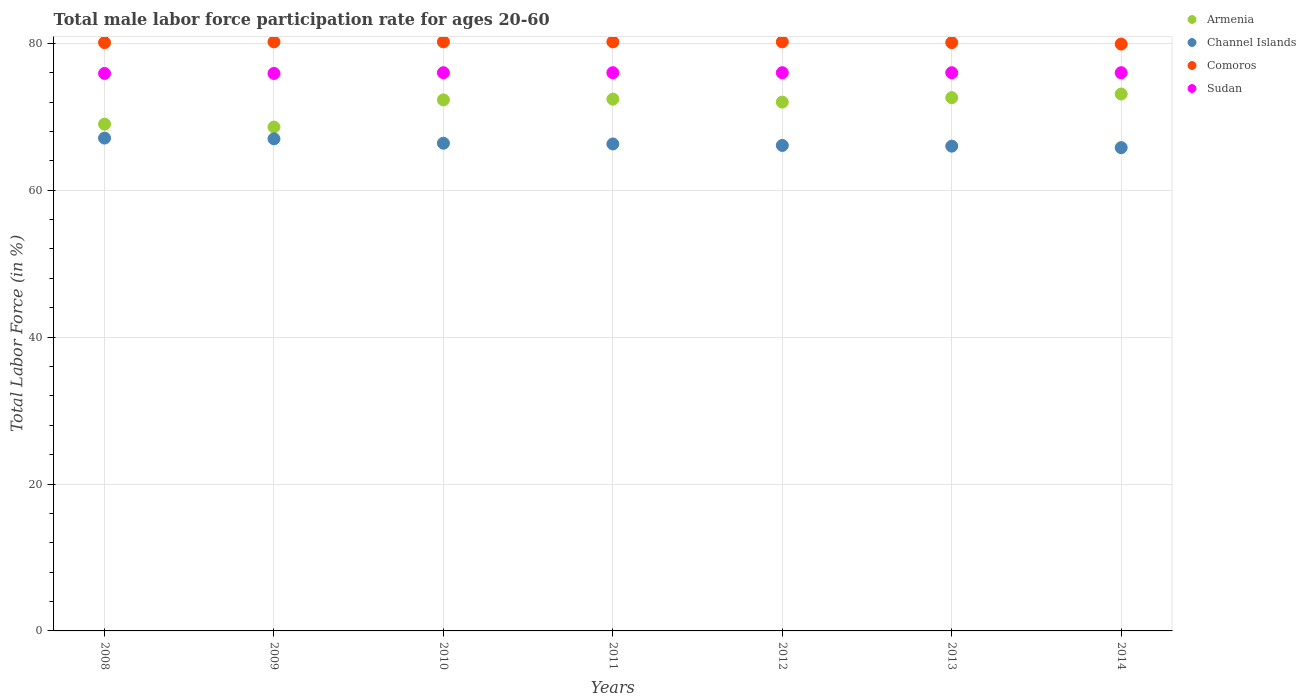How many different coloured dotlines are there?
Your answer should be compact. 4. Is the number of dotlines equal to the number of legend labels?
Provide a succinct answer. Yes. What is the male labor force participation rate in Sudan in 2012?
Your response must be concise. 76. Across all years, what is the maximum male labor force participation rate in Sudan?
Make the answer very short. 76. Across all years, what is the minimum male labor force participation rate in Comoros?
Keep it short and to the point. 79.9. In which year was the male labor force participation rate in Comoros minimum?
Your response must be concise. 2014. What is the total male labor force participation rate in Comoros in the graph?
Provide a short and direct response. 560.9. What is the difference between the male labor force participation rate in Channel Islands in 2009 and that in 2014?
Provide a short and direct response. 1.2. What is the difference between the male labor force participation rate in Comoros in 2011 and the male labor force participation rate in Armenia in 2008?
Your response must be concise. 11.2. What is the average male labor force participation rate in Channel Islands per year?
Offer a very short reply. 66.39. In the year 2008, what is the difference between the male labor force participation rate in Armenia and male labor force participation rate in Comoros?
Provide a succinct answer. -11.1. In how many years, is the male labor force participation rate in Channel Islands greater than 72 %?
Offer a very short reply. 0. What is the ratio of the male labor force participation rate in Sudan in 2009 to that in 2012?
Provide a short and direct response. 1. Is the difference between the male labor force participation rate in Armenia in 2012 and 2014 greater than the difference between the male labor force participation rate in Comoros in 2012 and 2014?
Provide a short and direct response. No. What is the difference between the highest and the lowest male labor force participation rate in Channel Islands?
Offer a very short reply. 1.3. Is the sum of the male labor force participation rate in Comoros in 2008 and 2011 greater than the maximum male labor force participation rate in Sudan across all years?
Provide a succinct answer. Yes. Is it the case that in every year, the sum of the male labor force participation rate in Armenia and male labor force participation rate in Channel Islands  is greater than the male labor force participation rate in Comoros?
Your answer should be compact. Yes. How many years are there in the graph?
Make the answer very short. 7. Are the values on the major ticks of Y-axis written in scientific E-notation?
Offer a terse response. No. Does the graph contain any zero values?
Provide a succinct answer. No. Does the graph contain grids?
Your response must be concise. Yes. How many legend labels are there?
Provide a succinct answer. 4. What is the title of the graph?
Your response must be concise. Total male labor force participation rate for ages 20-60. Does "Comoros" appear as one of the legend labels in the graph?
Make the answer very short. Yes. What is the label or title of the X-axis?
Keep it short and to the point. Years. What is the label or title of the Y-axis?
Provide a short and direct response. Total Labor Force (in %). What is the Total Labor Force (in %) of Armenia in 2008?
Your answer should be compact. 69. What is the Total Labor Force (in %) of Channel Islands in 2008?
Keep it short and to the point. 67.1. What is the Total Labor Force (in %) in Comoros in 2008?
Ensure brevity in your answer.  80.1. What is the Total Labor Force (in %) of Sudan in 2008?
Provide a succinct answer. 75.9. What is the Total Labor Force (in %) in Armenia in 2009?
Your answer should be very brief. 68.6. What is the Total Labor Force (in %) of Channel Islands in 2009?
Your answer should be very brief. 67. What is the Total Labor Force (in %) of Comoros in 2009?
Ensure brevity in your answer.  80.2. What is the Total Labor Force (in %) in Sudan in 2009?
Keep it short and to the point. 75.9. What is the Total Labor Force (in %) of Armenia in 2010?
Your answer should be very brief. 72.3. What is the Total Labor Force (in %) in Channel Islands in 2010?
Give a very brief answer. 66.4. What is the Total Labor Force (in %) of Comoros in 2010?
Offer a terse response. 80.2. What is the Total Labor Force (in %) of Sudan in 2010?
Your answer should be compact. 76. What is the Total Labor Force (in %) of Armenia in 2011?
Give a very brief answer. 72.4. What is the Total Labor Force (in %) of Channel Islands in 2011?
Provide a succinct answer. 66.3. What is the Total Labor Force (in %) of Comoros in 2011?
Keep it short and to the point. 80.2. What is the Total Labor Force (in %) of Sudan in 2011?
Provide a short and direct response. 76. What is the Total Labor Force (in %) of Armenia in 2012?
Your answer should be compact. 72. What is the Total Labor Force (in %) of Channel Islands in 2012?
Give a very brief answer. 66.1. What is the Total Labor Force (in %) of Comoros in 2012?
Your answer should be compact. 80.2. What is the Total Labor Force (in %) in Armenia in 2013?
Provide a short and direct response. 72.6. What is the Total Labor Force (in %) of Channel Islands in 2013?
Your answer should be compact. 66. What is the Total Labor Force (in %) of Comoros in 2013?
Provide a succinct answer. 80.1. What is the Total Labor Force (in %) of Armenia in 2014?
Your answer should be compact. 73.1. What is the Total Labor Force (in %) in Channel Islands in 2014?
Ensure brevity in your answer.  65.8. What is the Total Labor Force (in %) in Comoros in 2014?
Your answer should be very brief. 79.9. Across all years, what is the maximum Total Labor Force (in %) in Armenia?
Your answer should be compact. 73.1. Across all years, what is the maximum Total Labor Force (in %) in Channel Islands?
Offer a terse response. 67.1. Across all years, what is the maximum Total Labor Force (in %) of Comoros?
Keep it short and to the point. 80.2. Across all years, what is the maximum Total Labor Force (in %) of Sudan?
Ensure brevity in your answer.  76. Across all years, what is the minimum Total Labor Force (in %) in Armenia?
Make the answer very short. 68.6. Across all years, what is the minimum Total Labor Force (in %) in Channel Islands?
Ensure brevity in your answer.  65.8. Across all years, what is the minimum Total Labor Force (in %) of Comoros?
Keep it short and to the point. 79.9. Across all years, what is the minimum Total Labor Force (in %) in Sudan?
Make the answer very short. 75.9. What is the total Total Labor Force (in %) in Channel Islands in the graph?
Provide a short and direct response. 464.7. What is the total Total Labor Force (in %) in Comoros in the graph?
Give a very brief answer. 560.9. What is the total Total Labor Force (in %) of Sudan in the graph?
Make the answer very short. 531.8. What is the difference between the Total Labor Force (in %) of Armenia in 2008 and that in 2009?
Make the answer very short. 0.4. What is the difference between the Total Labor Force (in %) of Comoros in 2008 and that in 2009?
Offer a very short reply. -0.1. What is the difference between the Total Labor Force (in %) in Armenia in 2008 and that in 2010?
Provide a short and direct response. -3.3. What is the difference between the Total Labor Force (in %) of Sudan in 2008 and that in 2010?
Give a very brief answer. -0.1. What is the difference between the Total Labor Force (in %) of Armenia in 2008 and that in 2012?
Offer a terse response. -3. What is the difference between the Total Labor Force (in %) of Armenia in 2008 and that in 2013?
Ensure brevity in your answer.  -3.6. What is the difference between the Total Labor Force (in %) of Sudan in 2008 and that in 2013?
Offer a terse response. -0.1. What is the difference between the Total Labor Force (in %) of Armenia in 2009 and that in 2010?
Keep it short and to the point. -3.7. What is the difference between the Total Labor Force (in %) of Armenia in 2009 and that in 2011?
Your answer should be compact. -3.8. What is the difference between the Total Labor Force (in %) in Channel Islands in 2009 and that in 2012?
Give a very brief answer. 0.9. What is the difference between the Total Labor Force (in %) in Comoros in 2009 and that in 2012?
Offer a very short reply. 0. What is the difference between the Total Labor Force (in %) in Sudan in 2009 and that in 2012?
Keep it short and to the point. -0.1. What is the difference between the Total Labor Force (in %) in Channel Islands in 2009 and that in 2014?
Offer a very short reply. 1.2. What is the difference between the Total Labor Force (in %) of Sudan in 2009 and that in 2014?
Offer a very short reply. -0.1. What is the difference between the Total Labor Force (in %) in Armenia in 2010 and that in 2011?
Provide a succinct answer. -0.1. What is the difference between the Total Labor Force (in %) in Comoros in 2010 and that in 2011?
Your answer should be very brief. 0. What is the difference between the Total Labor Force (in %) of Sudan in 2010 and that in 2011?
Offer a terse response. 0. What is the difference between the Total Labor Force (in %) of Sudan in 2010 and that in 2012?
Your response must be concise. 0. What is the difference between the Total Labor Force (in %) in Channel Islands in 2010 and that in 2013?
Your answer should be compact. 0.4. What is the difference between the Total Labor Force (in %) of Comoros in 2010 and that in 2013?
Your answer should be compact. 0.1. What is the difference between the Total Labor Force (in %) of Sudan in 2010 and that in 2013?
Your response must be concise. 0. What is the difference between the Total Labor Force (in %) in Channel Islands in 2010 and that in 2014?
Offer a terse response. 0.6. What is the difference between the Total Labor Force (in %) in Sudan in 2010 and that in 2014?
Offer a terse response. 0. What is the difference between the Total Labor Force (in %) in Armenia in 2011 and that in 2012?
Give a very brief answer. 0.4. What is the difference between the Total Labor Force (in %) in Channel Islands in 2011 and that in 2013?
Offer a terse response. 0.3. What is the difference between the Total Labor Force (in %) of Sudan in 2011 and that in 2013?
Provide a succinct answer. 0. What is the difference between the Total Labor Force (in %) of Armenia in 2011 and that in 2014?
Your answer should be compact. -0.7. What is the difference between the Total Labor Force (in %) in Comoros in 2011 and that in 2014?
Give a very brief answer. 0.3. What is the difference between the Total Labor Force (in %) in Channel Islands in 2012 and that in 2013?
Ensure brevity in your answer.  0.1. What is the difference between the Total Labor Force (in %) of Sudan in 2012 and that in 2013?
Your response must be concise. 0. What is the difference between the Total Labor Force (in %) of Channel Islands in 2012 and that in 2014?
Offer a terse response. 0.3. What is the difference between the Total Labor Force (in %) of Comoros in 2012 and that in 2014?
Provide a short and direct response. 0.3. What is the difference between the Total Labor Force (in %) in Sudan in 2012 and that in 2014?
Give a very brief answer. 0. What is the difference between the Total Labor Force (in %) in Armenia in 2013 and that in 2014?
Offer a terse response. -0.5. What is the difference between the Total Labor Force (in %) of Channel Islands in 2013 and that in 2014?
Give a very brief answer. 0.2. What is the difference between the Total Labor Force (in %) of Comoros in 2013 and that in 2014?
Your response must be concise. 0.2. What is the difference between the Total Labor Force (in %) in Armenia in 2008 and the Total Labor Force (in %) in Channel Islands in 2009?
Ensure brevity in your answer.  2. What is the difference between the Total Labor Force (in %) in Armenia in 2008 and the Total Labor Force (in %) in Comoros in 2009?
Offer a terse response. -11.2. What is the difference between the Total Labor Force (in %) in Channel Islands in 2008 and the Total Labor Force (in %) in Sudan in 2009?
Give a very brief answer. -8.8. What is the difference between the Total Labor Force (in %) of Armenia in 2008 and the Total Labor Force (in %) of Channel Islands in 2010?
Offer a terse response. 2.6. What is the difference between the Total Labor Force (in %) of Channel Islands in 2008 and the Total Labor Force (in %) of Sudan in 2010?
Your answer should be very brief. -8.9. What is the difference between the Total Labor Force (in %) in Comoros in 2008 and the Total Labor Force (in %) in Sudan in 2010?
Your answer should be very brief. 4.1. What is the difference between the Total Labor Force (in %) of Armenia in 2008 and the Total Labor Force (in %) of Sudan in 2011?
Offer a terse response. -7. What is the difference between the Total Labor Force (in %) in Comoros in 2008 and the Total Labor Force (in %) in Sudan in 2011?
Ensure brevity in your answer.  4.1. What is the difference between the Total Labor Force (in %) in Armenia in 2008 and the Total Labor Force (in %) in Channel Islands in 2012?
Ensure brevity in your answer.  2.9. What is the difference between the Total Labor Force (in %) of Armenia in 2008 and the Total Labor Force (in %) of Comoros in 2012?
Offer a very short reply. -11.2. What is the difference between the Total Labor Force (in %) of Channel Islands in 2008 and the Total Labor Force (in %) of Sudan in 2012?
Provide a short and direct response. -8.9. What is the difference between the Total Labor Force (in %) of Comoros in 2008 and the Total Labor Force (in %) of Sudan in 2012?
Provide a succinct answer. 4.1. What is the difference between the Total Labor Force (in %) in Armenia in 2008 and the Total Labor Force (in %) in Sudan in 2013?
Offer a terse response. -7. What is the difference between the Total Labor Force (in %) of Comoros in 2008 and the Total Labor Force (in %) of Sudan in 2013?
Provide a succinct answer. 4.1. What is the difference between the Total Labor Force (in %) of Armenia in 2008 and the Total Labor Force (in %) of Sudan in 2014?
Provide a succinct answer. -7. What is the difference between the Total Labor Force (in %) of Channel Islands in 2008 and the Total Labor Force (in %) of Comoros in 2014?
Provide a succinct answer. -12.8. What is the difference between the Total Labor Force (in %) in Channel Islands in 2008 and the Total Labor Force (in %) in Sudan in 2014?
Your answer should be very brief. -8.9. What is the difference between the Total Labor Force (in %) of Channel Islands in 2009 and the Total Labor Force (in %) of Comoros in 2010?
Offer a very short reply. -13.2. What is the difference between the Total Labor Force (in %) in Channel Islands in 2009 and the Total Labor Force (in %) in Sudan in 2010?
Provide a succinct answer. -9. What is the difference between the Total Labor Force (in %) in Comoros in 2009 and the Total Labor Force (in %) in Sudan in 2010?
Your answer should be very brief. 4.2. What is the difference between the Total Labor Force (in %) in Armenia in 2009 and the Total Labor Force (in %) in Channel Islands in 2011?
Your answer should be compact. 2.3. What is the difference between the Total Labor Force (in %) of Armenia in 2009 and the Total Labor Force (in %) of Sudan in 2011?
Ensure brevity in your answer.  -7.4. What is the difference between the Total Labor Force (in %) in Channel Islands in 2009 and the Total Labor Force (in %) in Comoros in 2011?
Give a very brief answer. -13.2. What is the difference between the Total Labor Force (in %) of Channel Islands in 2009 and the Total Labor Force (in %) of Sudan in 2011?
Provide a succinct answer. -9. What is the difference between the Total Labor Force (in %) in Armenia in 2009 and the Total Labor Force (in %) in Channel Islands in 2012?
Your answer should be very brief. 2.5. What is the difference between the Total Labor Force (in %) of Channel Islands in 2009 and the Total Labor Force (in %) of Comoros in 2012?
Ensure brevity in your answer.  -13.2. What is the difference between the Total Labor Force (in %) in Channel Islands in 2009 and the Total Labor Force (in %) in Sudan in 2012?
Ensure brevity in your answer.  -9. What is the difference between the Total Labor Force (in %) in Comoros in 2009 and the Total Labor Force (in %) in Sudan in 2012?
Give a very brief answer. 4.2. What is the difference between the Total Labor Force (in %) of Armenia in 2009 and the Total Labor Force (in %) of Comoros in 2013?
Your answer should be compact. -11.5. What is the difference between the Total Labor Force (in %) in Channel Islands in 2009 and the Total Labor Force (in %) in Comoros in 2013?
Give a very brief answer. -13.1. What is the difference between the Total Labor Force (in %) of Channel Islands in 2009 and the Total Labor Force (in %) of Comoros in 2014?
Ensure brevity in your answer.  -12.9. What is the difference between the Total Labor Force (in %) in Armenia in 2010 and the Total Labor Force (in %) in Channel Islands in 2011?
Your response must be concise. 6. What is the difference between the Total Labor Force (in %) in Channel Islands in 2010 and the Total Labor Force (in %) in Comoros in 2011?
Keep it short and to the point. -13.8. What is the difference between the Total Labor Force (in %) of Channel Islands in 2010 and the Total Labor Force (in %) of Sudan in 2011?
Provide a short and direct response. -9.6. What is the difference between the Total Labor Force (in %) in Comoros in 2010 and the Total Labor Force (in %) in Sudan in 2011?
Make the answer very short. 4.2. What is the difference between the Total Labor Force (in %) of Channel Islands in 2010 and the Total Labor Force (in %) of Sudan in 2012?
Ensure brevity in your answer.  -9.6. What is the difference between the Total Labor Force (in %) of Comoros in 2010 and the Total Labor Force (in %) of Sudan in 2012?
Offer a very short reply. 4.2. What is the difference between the Total Labor Force (in %) of Armenia in 2010 and the Total Labor Force (in %) of Comoros in 2013?
Your response must be concise. -7.8. What is the difference between the Total Labor Force (in %) of Channel Islands in 2010 and the Total Labor Force (in %) of Comoros in 2013?
Keep it short and to the point. -13.7. What is the difference between the Total Labor Force (in %) in Comoros in 2010 and the Total Labor Force (in %) in Sudan in 2013?
Give a very brief answer. 4.2. What is the difference between the Total Labor Force (in %) of Channel Islands in 2010 and the Total Labor Force (in %) of Comoros in 2014?
Keep it short and to the point. -13.5. What is the difference between the Total Labor Force (in %) of Armenia in 2011 and the Total Labor Force (in %) of Channel Islands in 2012?
Keep it short and to the point. 6.3. What is the difference between the Total Labor Force (in %) in Armenia in 2011 and the Total Labor Force (in %) in Comoros in 2012?
Your answer should be very brief. -7.8. What is the difference between the Total Labor Force (in %) in Armenia in 2011 and the Total Labor Force (in %) in Sudan in 2012?
Make the answer very short. -3.6. What is the difference between the Total Labor Force (in %) in Comoros in 2011 and the Total Labor Force (in %) in Sudan in 2012?
Make the answer very short. 4.2. What is the difference between the Total Labor Force (in %) of Armenia in 2011 and the Total Labor Force (in %) of Comoros in 2013?
Provide a succinct answer. -7.7. What is the difference between the Total Labor Force (in %) in Channel Islands in 2011 and the Total Labor Force (in %) in Comoros in 2013?
Give a very brief answer. -13.8. What is the difference between the Total Labor Force (in %) in Channel Islands in 2011 and the Total Labor Force (in %) in Sudan in 2013?
Your answer should be very brief. -9.7. What is the difference between the Total Labor Force (in %) of Comoros in 2011 and the Total Labor Force (in %) of Sudan in 2013?
Make the answer very short. 4.2. What is the difference between the Total Labor Force (in %) in Armenia in 2011 and the Total Labor Force (in %) in Channel Islands in 2014?
Offer a very short reply. 6.6. What is the difference between the Total Labor Force (in %) in Armenia in 2011 and the Total Labor Force (in %) in Comoros in 2014?
Your response must be concise. -7.5. What is the difference between the Total Labor Force (in %) of Channel Islands in 2011 and the Total Labor Force (in %) of Comoros in 2014?
Ensure brevity in your answer.  -13.6. What is the difference between the Total Labor Force (in %) in Channel Islands in 2011 and the Total Labor Force (in %) in Sudan in 2014?
Ensure brevity in your answer.  -9.7. What is the difference between the Total Labor Force (in %) of Armenia in 2012 and the Total Labor Force (in %) of Channel Islands in 2013?
Offer a terse response. 6. What is the difference between the Total Labor Force (in %) in Armenia in 2012 and the Total Labor Force (in %) in Comoros in 2013?
Keep it short and to the point. -8.1. What is the difference between the Total Labor Force (in %) of Armenia in 2012 and the Total Labor Force (in %) of Sudan in 2013?
Make the answer very short. -4. What is the difference between the Total Labor Force (in %) in Channel Islands in 2012 and the Total Labor Force (in %) in Comoros in 2013?
Give a very brief answer. -14. What is the difference between the Total Labor Force (in %) in Channel Islands in 2012 and the Total Labor Force (in %) in Sudan in 2013?
Your answer should be compact. -9.9. What is the difference between the Total Labor Force (in %) of Armenia in 2012 and the Total Labor Force (in %) of Channel Islands in 2014?
Your answer should be very brief. 6.2. What is the difference between the Total Labor Force (in %) in Channel Islands in 2012 and the Total Labor Force (in %) in Sudan in 2014?
Keep it short and to the point. -9.9. What is the difference between the Total Labor Force (in %) of Armenia in 2013 and the Total Labor Force (in %) of Comoros in 2014?
Offer a very short reply. -7.3. What is the difference between the Total Labor Force (in %) of Channel Islands in 2013 and the Total Labor Force (in %) of Comoros in 2014?
Provide a short and direct response. -13.9. What is the difference between the Total Labor Force (in %) of Comoros in 2013 and the Total Labor Force (in %) of Sudan in 2014?
Provide a short and direct response. 4.1. What is the average Total Labor Force (in %) in Armenia per year?
Ensure brevity in your answer.  71.43. What is the average Total Labor Force (in %) in Channel Islands per year?
Your response must be concise. 66.39. What is the average Total Labor Force (in %) in Comoros per year?
Keep it short and to the point. 80.13. What is the average Total Labor Force (in %) of Sudan per year?
Provide a succinct answer. 75.97. In the year 2008, what is the difference between the Total Labor Force (in %) of Armenia and Total Labor Force (in %) of Channel Islands?
Offer a very short reply. 1.9. In the year 2008, what is the difference between the Total Labor Force (in %) of Channel Islands and Total Labor Force (in %) of Comoros?
Ensure brevity in your answer.  -13. In the year 2008, what is the difference between the Total Labor Force (in %) in Comoros and Total Labor Force (in %) in Sudan?
Your answer should be very brief. 4.2. In the year 2009, what is the difference between the Total Labor Force (in %) in Armenia and Total Labor Force (in %) in Comoros?
Offer a terse response. -11.6. In the year 2009, what is the difference between the Total Labor Force (in %) of Armenia and Total Labor Force (in %) of Sudan?
Make the answer very short. -7.3. In the year 2010, what is the difference between the Total Labor Force (in %) in Armenia and Total Labor Force (in %) in Channel Islands?
Offer a terse response. 5.9. In the year 2010, what is the difference between the Total Labor Force (in %) of Channel Islands and Total Labor Force (in %) of Comoros?
Make the answer very short. -13.8. In the year 2010, what is the difference between the Total Labor Force (in %) of Channel Islands and Total Labor Force (in %) of Sudan?
Offer a very short reply. -9.6. In the year 2011, what is the difference between the Total Labor Force (in %) of Armenia and Total Labor Force (in %) of Channel Islands?
Your answer should be compact. 6.1. In the year 2011, what is the difference between the Total Labor Force (in %) in Channel Islands and Total Labor Force (in %) in Comoros?
Give a very brief answer. -13.9. In the year 2012, what is the difference between the Total Labor Force (in %) of Armenia and Total Labor Force (in %) of Channel Islands?
Provide a succinct answer. 5.9. In the year 2012, what is the difference between the Total Labor Force (in %) in Armenia and Total Labor Force (in %) in Comoros?
Make the answer very short. -8.2. In the year 2012, what is the difference between the Total Labor Force (in %) in Channel Islands and Total Labor Force (in %) in Comoros?
Provide a short and direct response. -14.1. In the year 2013, what is the difference between the Total Labor Force (in %) in Armenia and Total Labor Force (in %) in Comoros?
Your response must be concise. -7.5. In the year 2013, what is the difference between the Total Labor Force (in %) in Armenia and Total Labor Force (in %) in Sudan?
Make the answer very short. -3.4. In the year 2013, what is the difference between the Total Labor Force (in %) of Channel Islands and Total Labor Force (in %) of Comoros?
Your response must be concise. -14.1. In the year 2013, what is the difference between the Total Labor Force (in %) of Channel Islands and Total Labor Force (in %) of Sudan?
Offer a terse response. -10. In the year 2014, what is the difference between the Total Labor Force (in %) of Armenia and Total Labor Force (in %) of Comoros?
Offer a very short reply. -6.8. In the year 2014, what is the difference between the Total Labor Force (in %) of Channel Islands and Total Labor Force (in %) of Comoros?
Your answer should be compact. -14.1. In the year 2014, what is the difference between the Total Labor Force (in %) in Channel Islands and Total Labor Force (in %) in Sudan?
Offer a very short reply. -10.2. In the year 2014, what is the difference between the Total Labor Force (in %) of Comoros and Total Labor Force (in %) of Sudan?
Give a very brief answer. 3.9. What is the ratio of the Total Labor Force (in %) in Armenia in 2008 to that in 2009?
Your answer should be compact. 1.01. What is the ratio of the Total Labor Force (in %) in Armenia in 2008 to that in 2010?
Your answer should be very brief. 0.95. What is the ratio of the Total Labor Force (in %) in Channel Islands in 2008 to that in 2010?
Offer a very short reply. 1.01. What is the ratio of the Total Labor Force (in %) of Armenia in 2008 to that in 2011?
Your answer should be compact. 0.95. What is the ratio of the Total Labor Force (in %) of Channel Islands in 2008 to that in 2011?
Your response must be concise. 1.01. What is the ratio of the Total Labor Force (in %) of Comoros in 2008 to that in 2011?
Ensure brevity in your answer.  1. What is the ratio of the Total Labor Force (in %) in Channel Islands in 2008 to that in 2012?
Keep it short and to the point. 1.02. What is the ratio of the Total Labor Force (in %) in Comoros in 2008 to that in 2012?
Make the answer very short. 1. What is the ratio of the Total Labor Force (in %) in Sudan in 2008 to that in 2012?
Ensure brevity in your answer.  1. What is the ratio of the Total Labor Force (in %) in Armenia in 2008 to that in 2013?
Offer a very short reply. 0.95. What is the ratio of the Total Labor Force (in %) of Channel Islands in 2008 to that in 2013?
Your response must be concise. 1.02. What is the ratio of the Total Labor Force (in %) in Armenia in 2008 to that in 2014?
Give a very brief answer. 0.94. What is the ratio of the Total Labor Force (in %) in Channel Islands in 2008 to that in 2014?
Ensure brevity in your answer.  1.02. What is the ratio of the Total Labor Force (in %) in Sudan in 2008 to that in 2014?
Provide a short and direct response. 1. What is the ratio of the Total Labor Force (in %) of Armenia in 2009 to that in 2010?
Make the answer very short. 0.95. What is the ratio of the Total Labor Force (in %) in Channel Islands in 2009 to that in 2010?
Offer a terse response. 1.01. What is the ratio of the Total Labor Force (in %) of Armenia in 2009 to that in 2011?
Your answer should be compact. 0.95. What is the ratio of the Total Labor Force (in %) in Channel Islands in 2009 to that in 2011?
Provide a short and direct response. 1.01. What is the ratio of the Total Labor Force (in %) in Armenia in 2009 to that in 2012?
Your answer should be very brief. 0.95. What is the ratio of the Total Labor Force (in %) of Channel Islands in 2009 to that in 2012?
Your answer should be compact. 1.01. What is the ratio of the Total Labor Force (in %) of Comoros in 2009 to that in 2012?
Your answer should be compact. 1. What is the ratio of the Total Labor Force (in %) in Sudan in 2009 to that in 2012?
Your response must be concise. 1. What is the ratio of the Total Labor Force (in %) in Armenia in 2009 to that in 2013?
Ensure brevity in your answer.  0.94. What is the ratio of the Total Labor Force (in %) of Channel Islands in 2009 to that in 2013?
Your response must be concise. 1.02. What is the ratio of the Total Labor Force (in %) in Sudan in 2009 to that in 2013?
Provide a succinct answer. 1. What is the ratio of the Total Labor Force (in %) of Armenia in 2009 to that in 2014?
Make the answer very short. 0.94. What is the ratio of the Total Labor Force (in %) of Channel Islands in 2009 to that in 2014?
Offer a very short reply. 1.02. What is the ratio of the Total Labor Force (in %) in Comoros in 2009 to that in 2014?
Give a very brief answer. 1. What is the ratio of the Total Labor Force (in %) in Armenia in 2010 to that in 2011?
Provide a short and direct response. 1. What is the ratio of the Total Labor Force (in %) of Channel Islands in 2010 to that in 2011?
Keep it short and to the point. 1. What is the ratio of the Total Labor Force (in %) in Comoros in 2010 to that in 2011?
Your response must be concise. 1. What is the ratio of the Total Labor Force (in %) of Sudan in 2010 to that in 2011?
Your answer should be very brief. 1. What is the ratio of the Total Labor Force (in %) of Armenia in 2010 to that in 2012?
Offer a terse response. 1. What is the ratio of the Total Labor Force (in %) in Channel Islands in 2010 to that in 2012?
Keep it short and to the point. 1. What is the ratio of the Total Labor Force (in %) in Comoros in 2010 to that in 2012?
Ensure brevity in your answer.  1. What is the ratio of the Total Labor Force (in %) of Sudan in 2010 to that in 2012?
Keep it short and to the point. 1. What is the ratio of the Total Labor Force (in %) of Channel Islands in 2010 to that in 2013?
Provide a short and direct response. 1.01. What is the ratio of the Total Labor Force (in %) of Comoros in 2010 to that in 2013?
Your answer should be compact. 1. What is the ratio of the Total Labor Force (in %) of Sudan in 2010 to that in 2013?
Your response must be concise. 1. What is the ratio of the Total Labor Force (in %) in Armenia in 2010 to that in 2014?
Give a very brief answer. 0.99. What is the ratio of the Total Labor Force (in %) in Channel Islands in 2010 to that in 2014?
Provide a short and direct response. 1.01. What is the ratio of the Total Labor Force (in %) in Armenia in 2011 to that in 2012?
Give a very brief answer. 1.01. What is the ratio of the Total Labor Force (in %) of Channel Islands in 2011 to that in 2012?
Keep it short and to the point. 1. What is the ratio of the Total Labor Force (in %) of Comoros in 2011 to that in 2012?
Provide a succinct answer. 1. What is the ratio of the Total Labor Force (in %) in Sudan in 2011 to that in 2012?
Give a very brief answer. 1. What is the ratio of the Total Labor Force (in %) in Armenia in 2011 to that in 2013?
Provide a short and direct response. 1. What is the ratio of the Total Labor Force (in %) in Channel Islands in 2011 to that in 2013?
Your response must be concise. 1. What is the ratio of the Total Labor Force (in %) of Sudan in 2011 to that in 2013?
Provide a succinct answer. 1. What is the ratio of the Total Labor Force (in %) in Channel Islands in 2011 to that in 2014?
Provide a succinct answer. 1.01. What is the ratio of the Total Labor Force (in %) of Armenia in 2012 to that in 2013?
Provide a short and direct response. 0.99. What is the ratio of the Total Labor Force (in %) of Comoros in 2012 to that in 2013?
Offer a very short reply. 1. What is the ratio of the Total Labor Force (in %) in Sudan in 2012 to that in 2013?
Your answer should be compact. 1. What is the ratio of the Total Labor Force (in %) of Comoros in 2012 to that in 2014?
Provide a succinct answer. 1. What is the ratio of the Total Labor Force (in %) of Channel Islands in 2013 to that in 2014?
Your answer should be compact. 1. What is the ratio of the Total Labor Force (in %) of Comoros in 2013 to that in 2014?
Offer a very short reply. 1. What is the difference between the highest and the second highest Total Labor Force (in %) in Armenia?
Give a very brief answer. 0.5. What is the difference between the highest and the second highest Total Labor Force (in %) of Comoros?
Give a very brief answer. 0. What is the difference between the highest and the lowest Total Labor Force (in %) of Sudan?
Offer a very short reply. 0.1. 